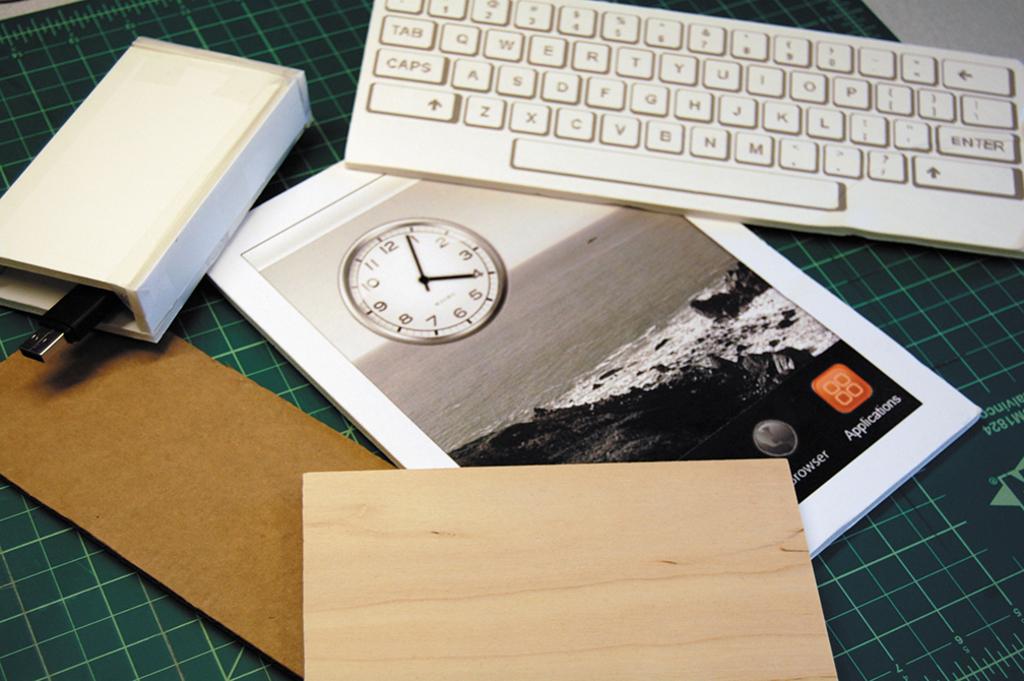What time is it?
Your answer should be very brief. 4:04. 